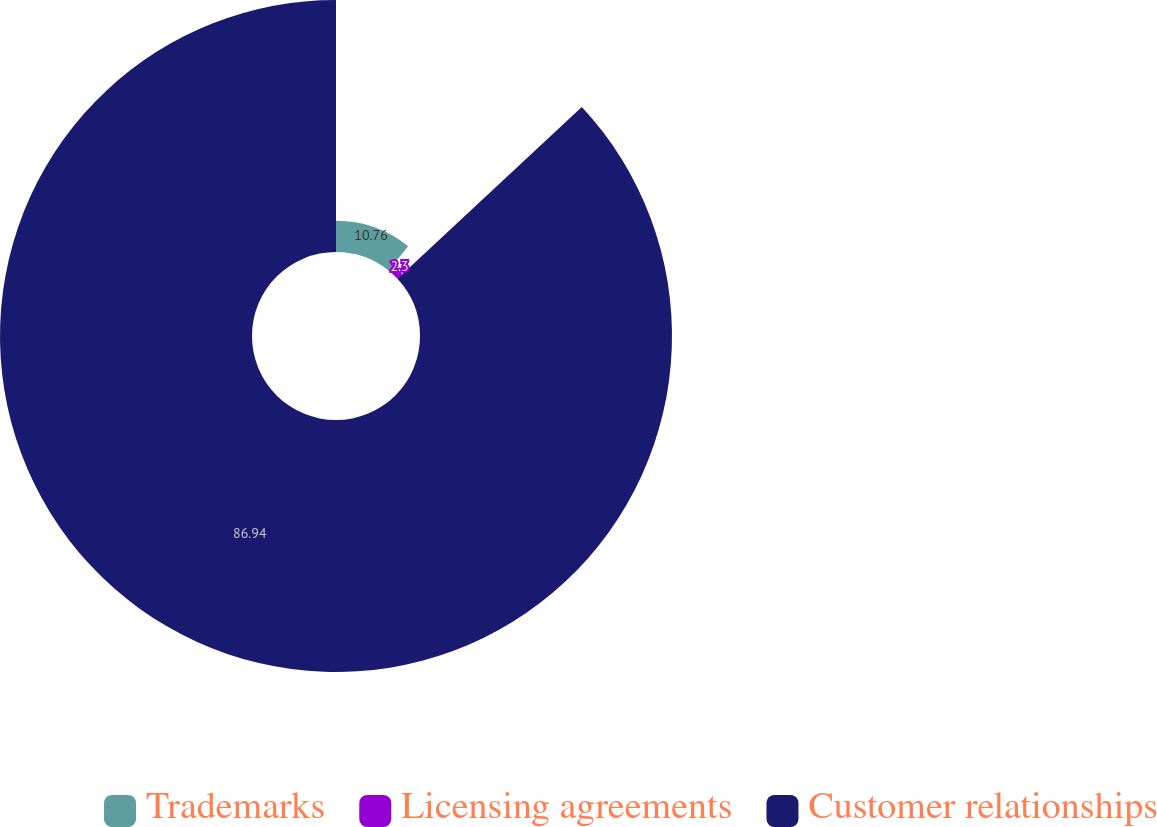Convert chart to OTSL. <chart><loc_0><loc_0><loc_500><loc_500><pie_chart><fcel>Trademarks<fcel>Licensing agreements<fcel>Customer relationships<nl><fcel>10.76%<fcel>2.3%<fcel>86.94%<nl></chart> 